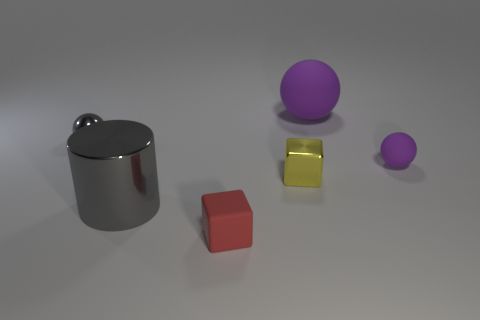Subtract all purple balls. How many were subtracted if there are1purple balls left? 1 Subtract all tiny gray metallic balls. How many balls are left? 2 Add 2 large brown blocks. How many objects exist? 8 Subtract 1 blocks. How many blocks are left? 1 Add 4 metal cylinders. How many metal cylinders are left? 5 Add 5 blue objects. How many blue objects exist? 5 Subtract all yellow blocks. How many blocks are left? 1 Subtract 1 red cubes. How many objects are left? 5 Subtract all cylinders. How many objects are left? 5 Subtract all purple balls. Subtract all yellow cylinders. How many balls are left? 1 